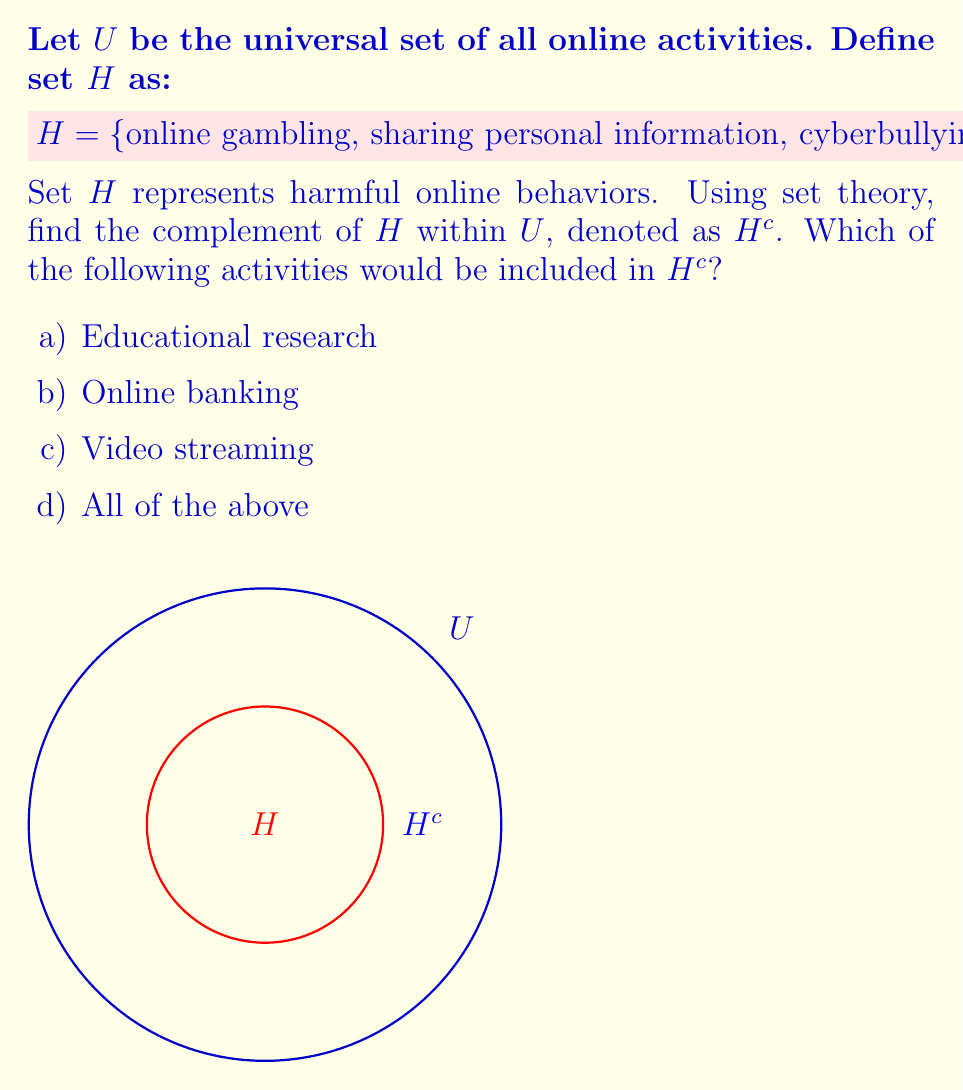Could you help me with this problem? To solve this problem, we need to understand the concept of set complement:

1) The complement of a set $H$ within a universal set $U$, denoted as $H^c$, contains all elements in $U$ that are not in $H$.

2) Mathematically, this is expressed as:

   $H^c = \{x \in U : x \notin H\}$

3) In this case, $H^c$ would include all online activities that are not considered harmful.

4) Looking at the given options:
   a) Educational research is a productive online activity, not harmful.
   b) Online banking is a useful financial tool, not harmful.
   c) Video streaming is a form of entertainment, not inherently harmful.

5) All of these activities (a, b, and c) are not in set $H$, therefore they would be in $H^c$.

6) The correct answer is thus "d) All of the above".

This answer aligns with the conservative perspective that views certain online activities as harmful while recognizing the beneficial aspects of responsible internet use.
Answer: d) All of the above 